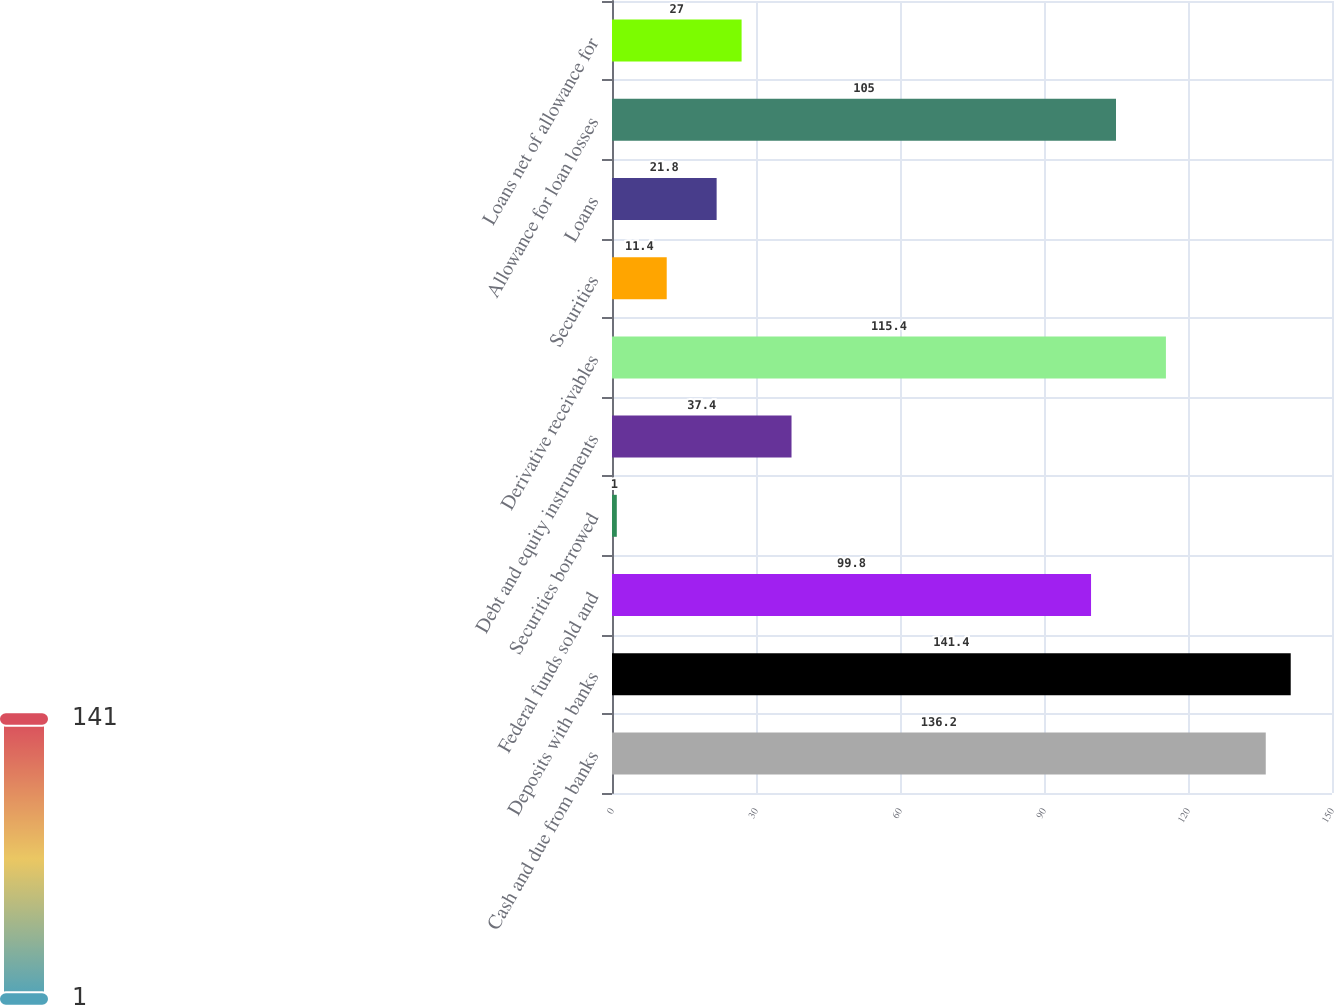<chart> <loc_0><loc_0><loc_500><loc_500><bar_chart><fcel>Cash and due from banks<fcel>Deposits with banks<fcel>Federal funds sold and<fcel>Securities borrowed<fcel>Debt and equity instruments<fcel>Derivative receivables<fcel>Securities<fcel>Loans<fcel>Allowance for loan losses<fcel>Loans net of allowance for<nl><fcel>136.2<fcel>141.4<fcel>99.8<fcel>1<fcel>37.4<fcel>115.4<fcel>11.4<fcel>21.8<fcel>105<fcel>27<nl></chart> 